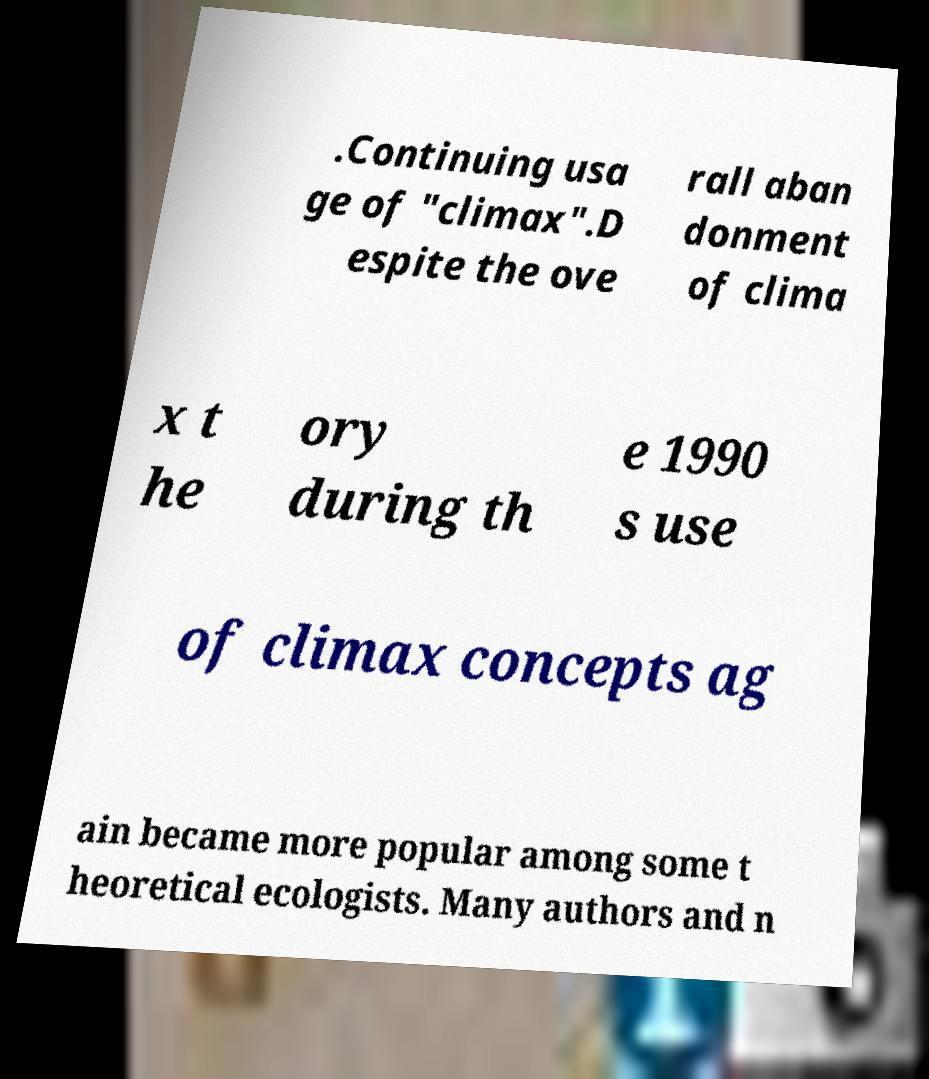Please identify and transcribe the text found in this image. .Continuing usa ge of "climax".D espite the ove rall aban donment of clima x t he ory during th e 1990 s use of climax concepts ag ain became more popular among some t heoretical ecologists. Many authors and n 